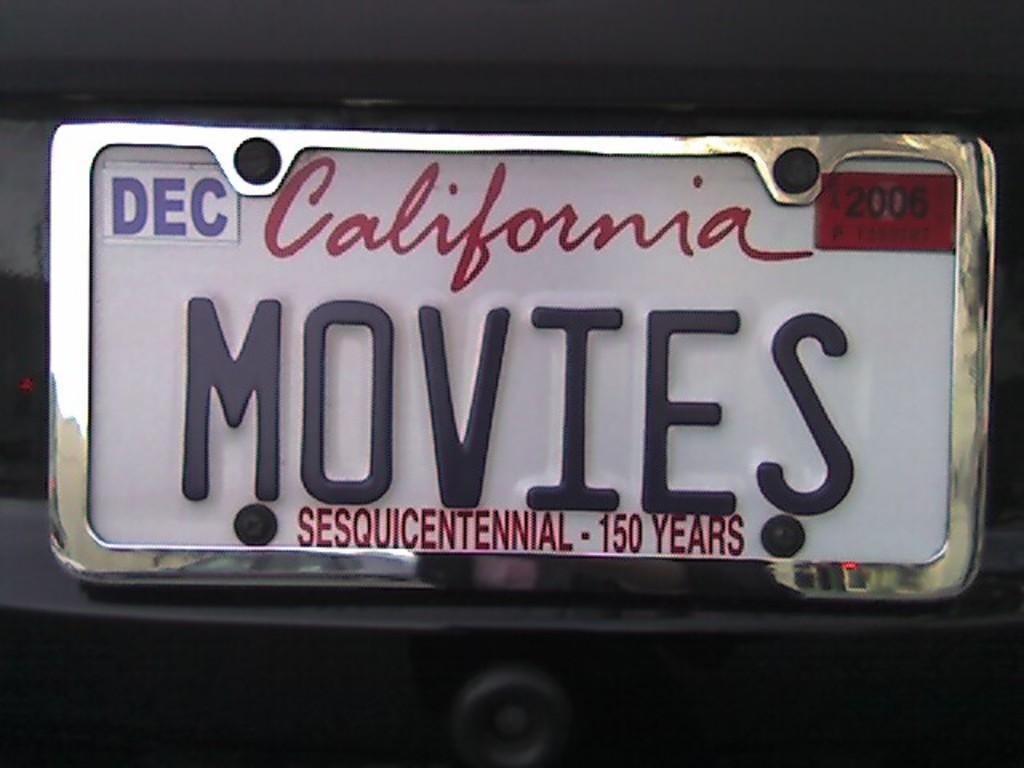What state is this from?
Offer a terse response. California. 